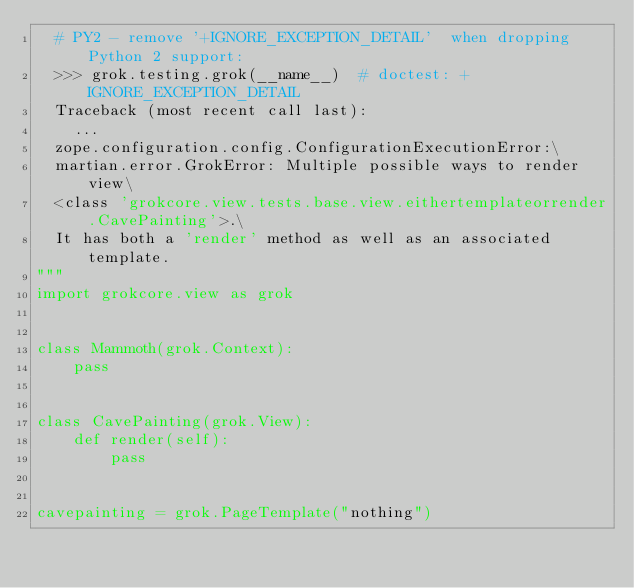<code> <loc_0><loc_0><loc_500><loc_500><_Python_>  # PY2 - remove '+IGNORE_EXCEPTION_DETAIL'  when dropping Python 2 support:
  >>> grok.testing.grok(__name__)  # doctest: +IGNORE_EXCEPTION_DETAIL
  Traceback (most recent call last):
    ...
  zope.configuration.config.ConfigurationExecutionError:\
  martian.error.GrokError: Multiple possible ways to render view\
  <class 'grokcore.view.tests.base.view.eithertemplateorrender.CavePainting'>.\
  It has both a 'render' method as well as an associated template.
"""
import grokcore.view as grok


class Mammoth(grok.Context):
    pass


class CavePainting(grok.View):
    def render(self):
        pass


cavepainting = grok.PageTemplate("nothing")
</code> 